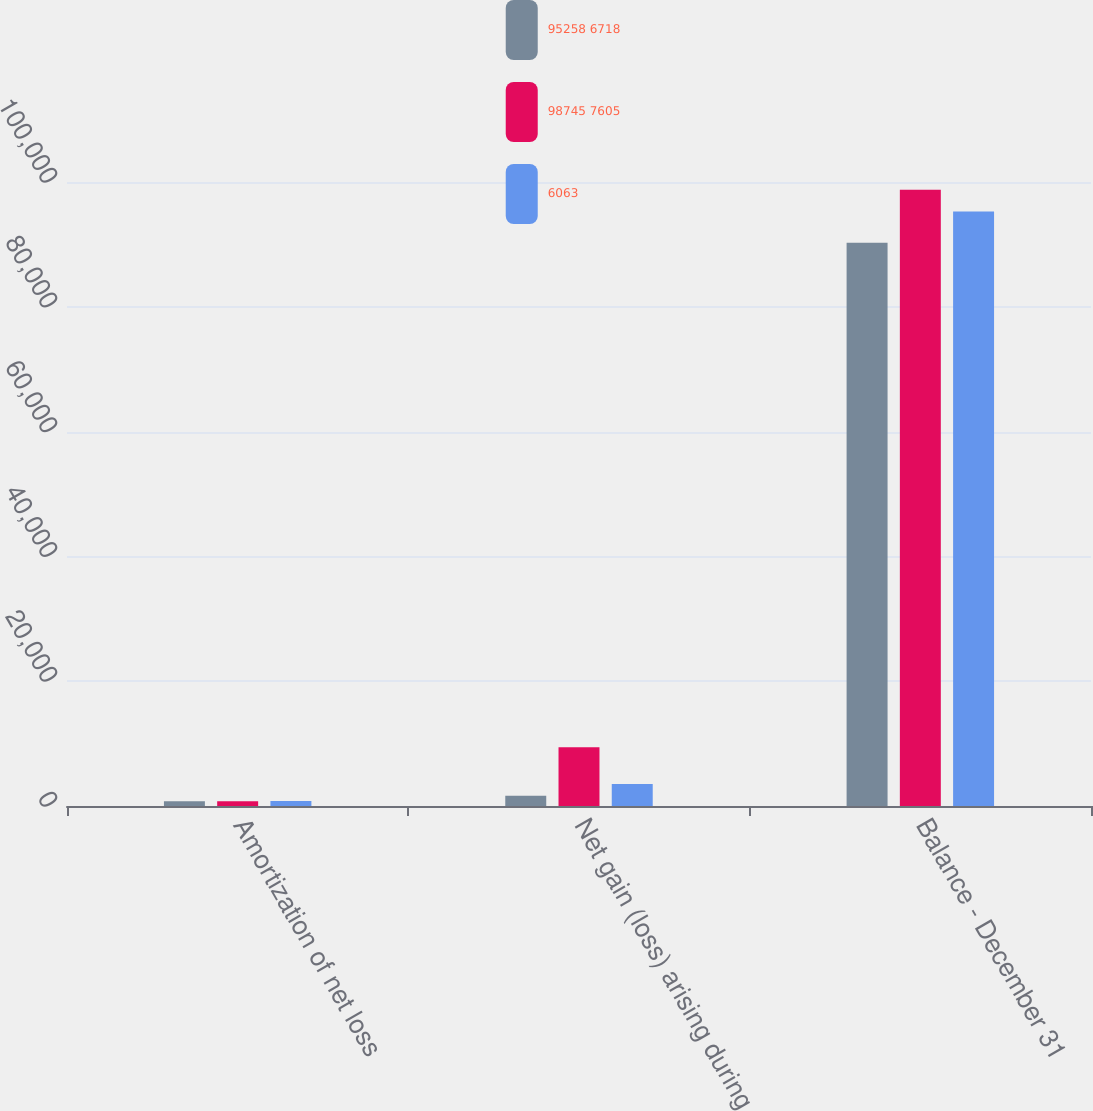Convert chart. <chart><loc_0><loc_0><loc_500><loc_500><stacked_bar_chart><ecel><fcel>Amortization of net loss<fcel>Net gain (loss) arising during<fcel>Balance - December 31<nl><fcel>95258 6718<fcel>773<fcel>1643<fcel>90270<nl><fcel>98745 7605<fcel>771<fcel>9434<fcel>98745<nl><fcel>6063<fcel>791<fcel>3509<fcel>95258<nl></chart> 